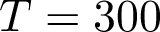Convert formula to latex. <formula><loc_0><loc_0><loc_500><loc_500>T = 3 0 0</formula> 